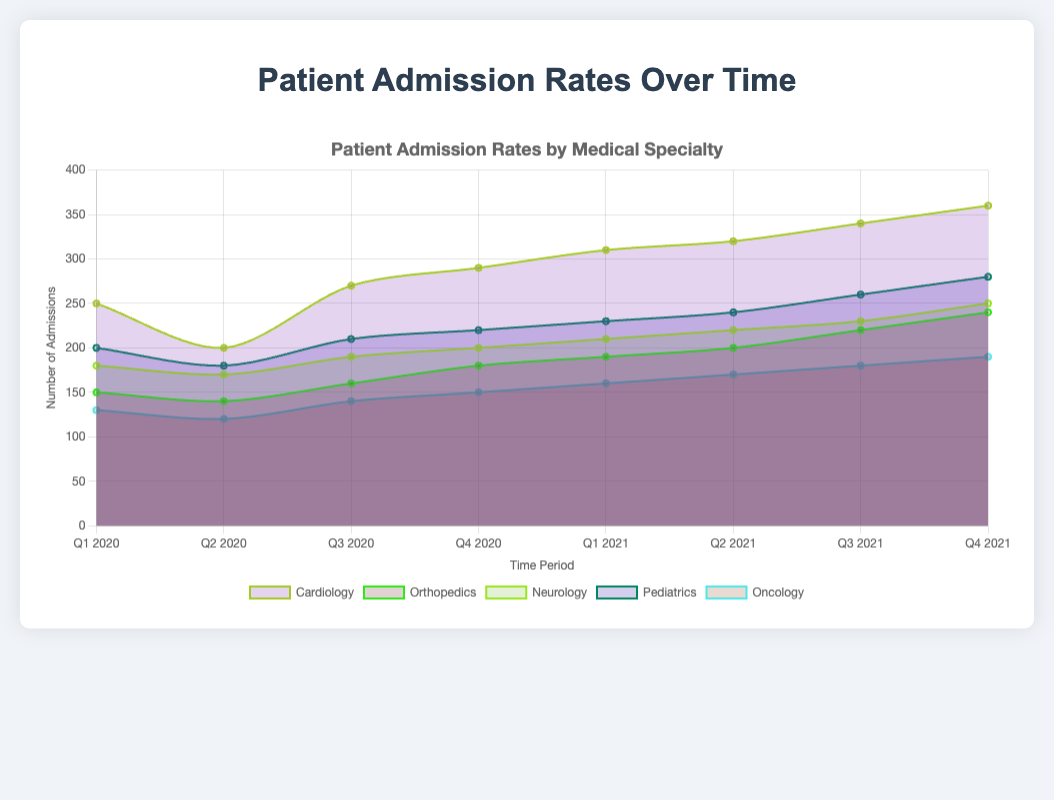What are the time periods displayed on the chart? The chart's x-axis shows the time periods for the data points. These periods are labeled from Q1 2020 to Q4 2021.
Answer: Q1 2020 to Q4 2021 Which specialty had the highest number of admissions in Q4 2021? By looking at the topmost layer in the chart at Q4 2021, Cardiology has the highest number of admissions with 360.
Answer: Cardiology How did the number of admissions in Oncology change from Q1 2020 to Q4 2021? Observe the area representing Oncology from Q1 2020 to Q4 2021. It starts at 130 and ends at 190, indicating an increase.
Answer: Increased from 130 to 190 Which specialty showed the most consistent growth over the periods? Consistency can be observed by checking for a steady upward trend in the area. Cardiology exhibits a consistent increase in admissions from Q1 2020 to Q4 2021.
Answer: Cardiology What was the difference in the number of admissions between Neurology and Orthopedics in Q2 2020? In Q2 2020, Neurology had 170 admissions and Orthopedics had 140. The difference is 170 - 140.
Answer: 30 Which two specialties had the closest number of admissions in Q3 2021? By comparing the heights in Q3 2021, Neurology (230) and Pediatrics (260) are the closest, with a difference of 30.
Answer: Neurology and Pediatrics From which quarter did Cardiology begin to show a noticeable increase in the number of admissions? Observe the Cardiology trend; a noticeable increase starts from Q2 2020 compared to its previous period.
Answer: Q2 2020 How does the trend of Pediatric admissions compare with Orthopedic admissions over time? Both specialties show an upward trend, but Pediatrics had a higher starting point and maintained a lead over Orthopedics consistently. - Starting point for Pediatrics is 200 in Q1 2020 and for Orthopedics is 150. - Both increased steadily throughout the time period. - Ending point for Pediatrics is 280 in Q4 2021 and for Orthopedics is 240.
Answer: Pediatrics consistently higher than Orthopedics What is the average number of admissions for Oncology over the entire period? Summing the admissions for Oncology (130 + 120 + 140 + 150 + 160 + 170 + 180 + 190) gives 1240. There are 8 quarters, so the average is 1240/8.
Answer: 155 